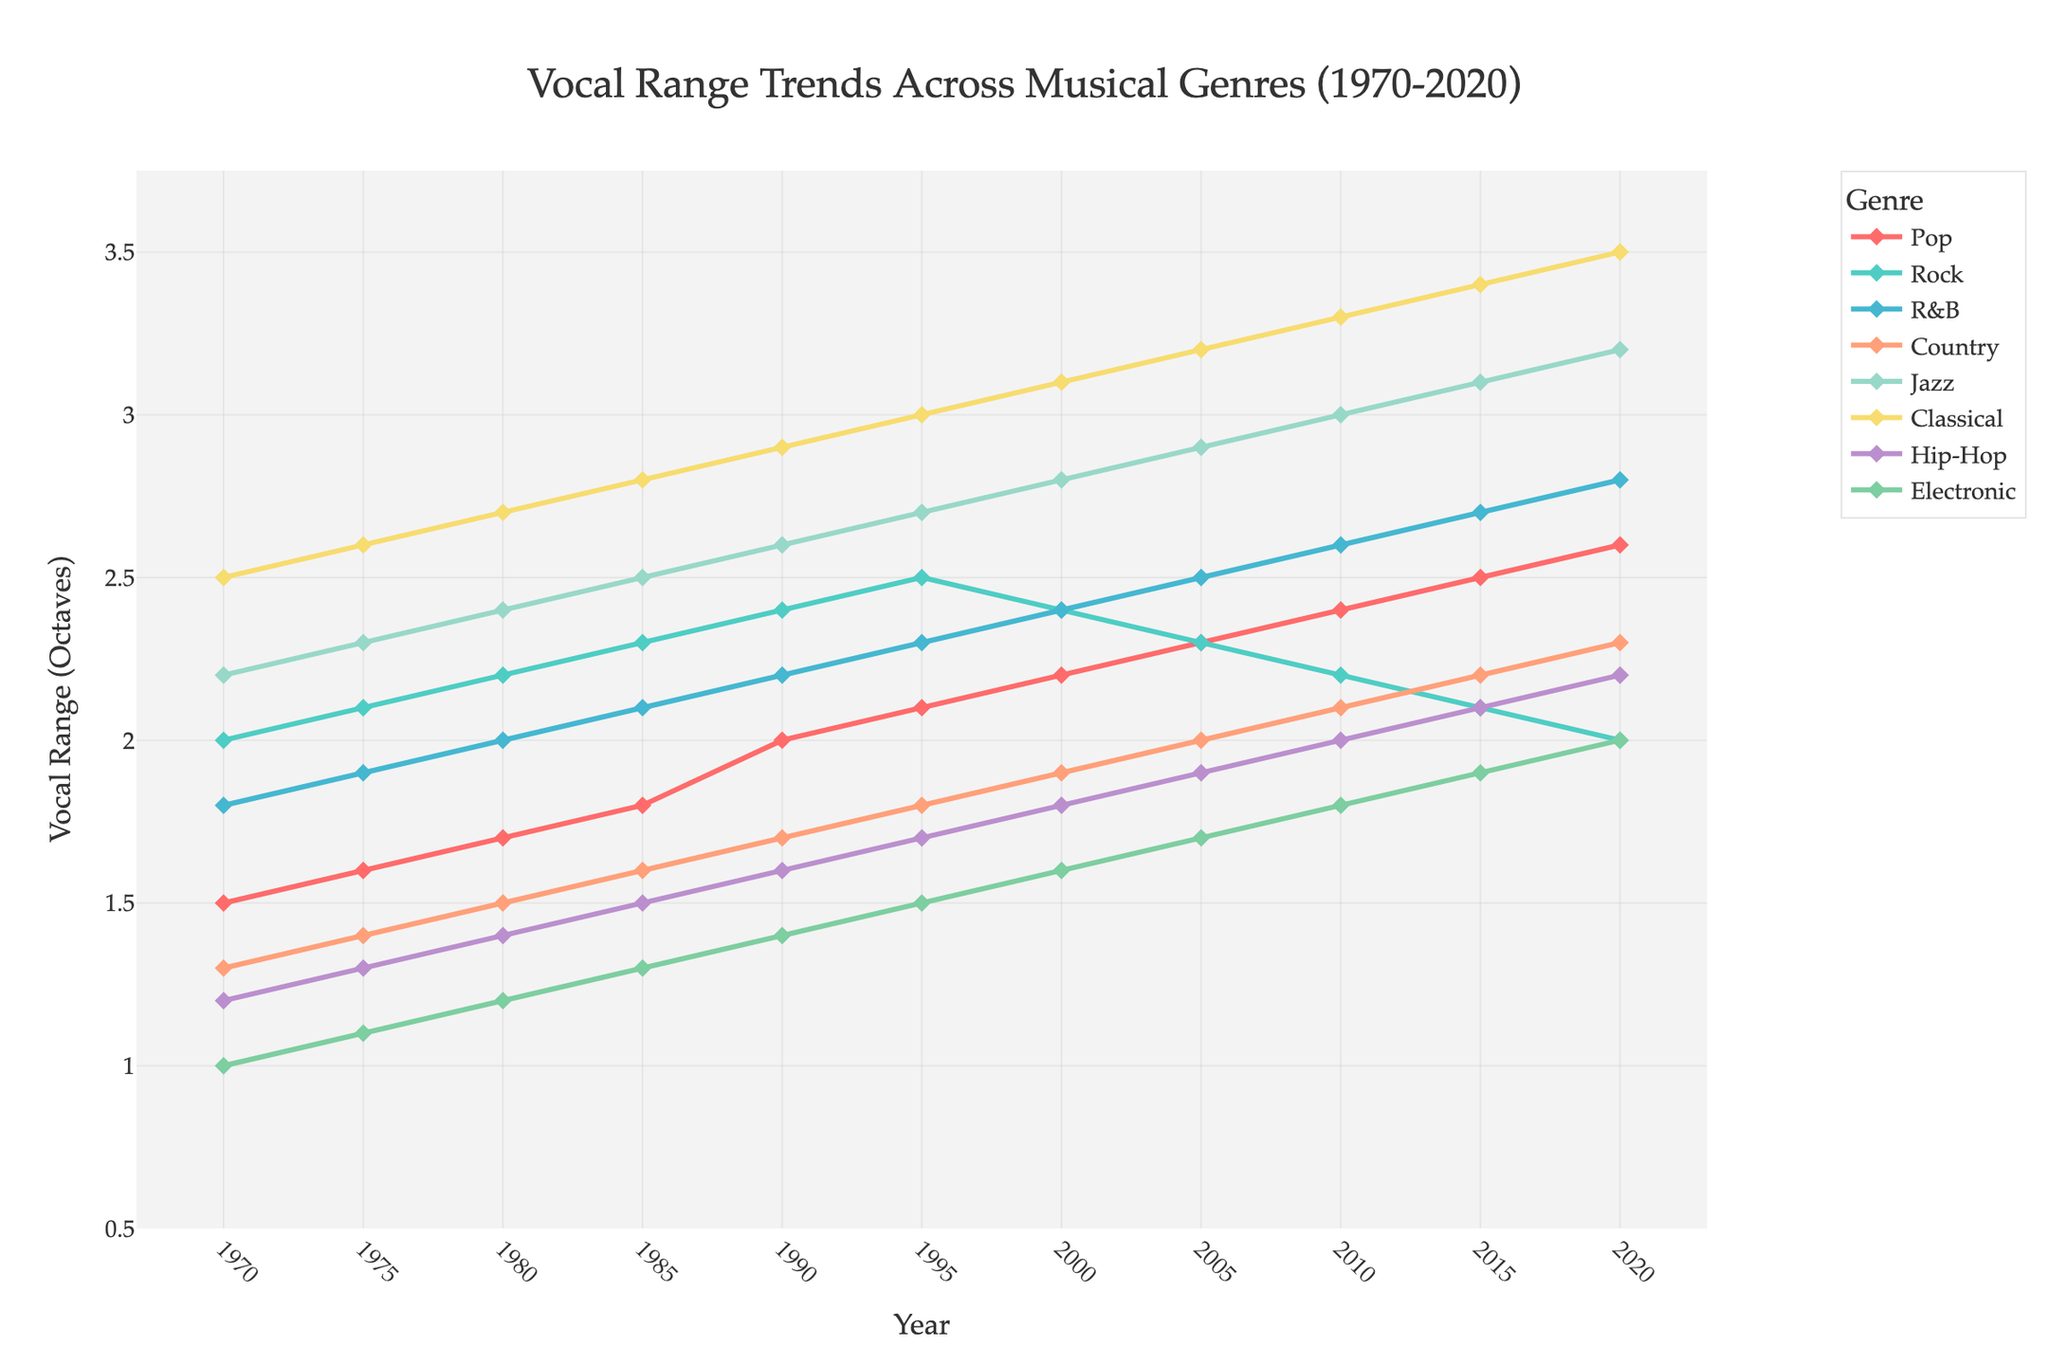What is the general trend for the vocal range in Pop music from 1970 to 2020? To find the trend for Pop music, look at the line for Pop in the plot. From 1970 to 2020, the vocal range steadily increased from 1.5 to 2.6 octaves.
Answer: Steady increase Which genre had the highest vocal range in 2020? To identify the genre with the highest vocal range, look at the values for each genre in 2020. Classical has a vocal range of 3.5 octaves, which is the highest.
Answer: Classical Compare the trends between Rock and Hip-Hop from 2000 to 2020. Which genre's vocal range increased, and which decreased? Examine the lines for Rock and Hip-Hop between 2000 and 2020. Rock's vocal range decreased from 2.4 to 2.0, whereas Hip-Hop's vocal range increased from 1.8 to 2.2.
Answer: Rock decreased, Hip-Hop increased Between 1990 and 2010, which genre had the greatest increase in vocal range? Calculate the difference in vocal range between 1990 and 2010 for each genre. R&B increased from 2.2 to 2.6, resulting in an increase of 0.4 octaves, which is the greatest among the genres.
Answer: R&B Which genre displayed the most stable vocal range over the 50 years? Stability can be inferred by observing the gentleness of the trend line's slope. Rock shows the smallest fluctuations, maintaining a range between 2.0 and 2.5.
Answer: Rock How does the change in vocal range for Jazz compare to Pop from 1970 to 2020? Calculate the increase for both genres from 1970 to 2020. Jazz increased from 2.2 to 3.2 (1.0 octave), and Pop increased from 1.5 to 2.6 (1.1 octaves).
Answer: Similar In 2020, which genre had a vocal range closest to 2 octaves? Look at the 2020 values for all genres. Electronic has a vocal range of 2.0 octaves, which is closest to 2 octaves.
Answer: Electronic Which two genres had intersecting trends around the year 1995? Observe the intersecting points of the trend lines. Pop and Country's vocal ranges intersected around 1995.
Answer: Pop and Country What is the average vocal range of Classical music from 1970 to 2020? Sum the vocal ranges for Classical over the years and divide by the number of data points (11). The sum is 30.5, and the average is 30.5/11 ≈ 2.77.
Answer: 2.77 If all genres continued their trends, which would you predict to have the highest vocal range by 2025? Extend the current trends to 2025. Classical's trend shows the fastest increase, likely continuing to be the highest by 2025.
Answer: Classical 